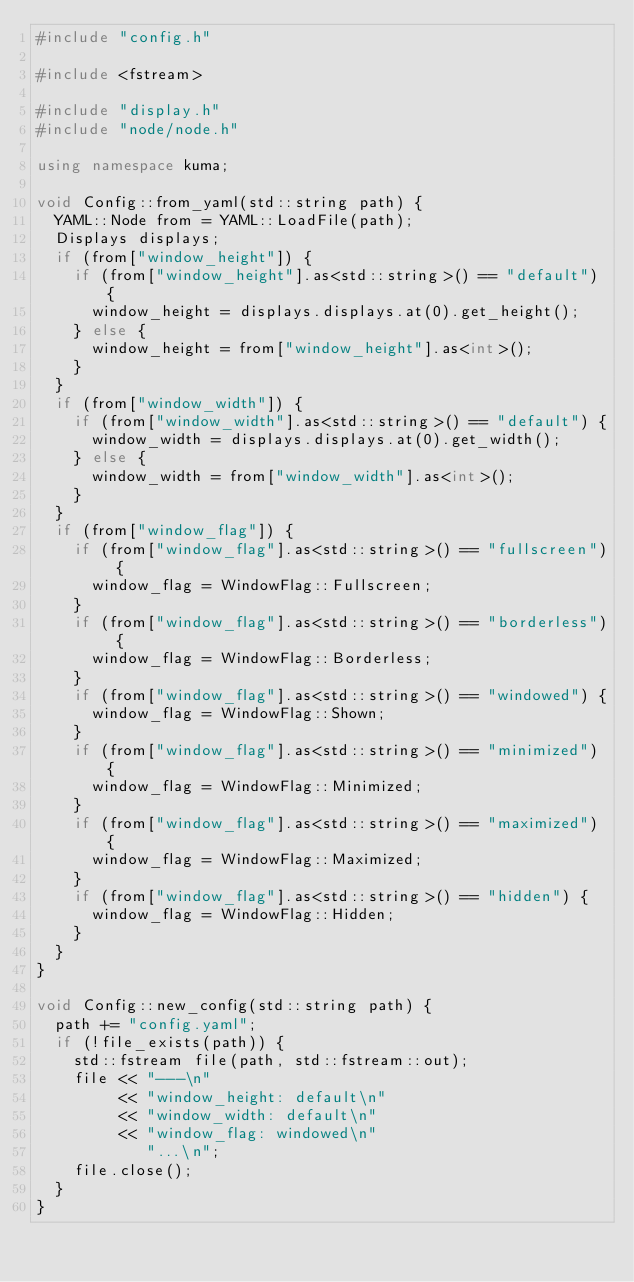<code> <loc_0><loc_0><loc_500><loc_500><_C++_>#include "config.h"

#include <fstream>

#include "display.h"
#include "node/node.h"

using namespace kuma;

void Config::from_yaml(std::string path) {
	YAML::Node from = YAML::LoadFile(path);
	Displays displays;
	if (from["window_height"]) {
		if (from["window_height"].as<std::string>() == "default") {
			window_height = displays.displays.at(0).get_height();
		} else {
			window_height = from["window_height"].as<int>();
		}
	}
	if (from["window_width"]) {
		if (from["window_width"].as<std::string>() == "default") {
			window_width = displays.displays.at(0).get_width();
		} else {
			window_width = from["window_width"].as<int>();
		}
	}
	if (from["window_flag"]) {
		if (from["window_flag"].as<std::string>() == "fullscreen") {
			window_flag = WindowFlag::Fullscreen;
		}
		if (from["window_flag"].as<std::string>() == "borderless") {
			window_flag = WindowFlag::Borderless;
		}
		if (from["window_flag"].as<std::string>() == "windowed") {
			window_flag = WindowFlag::Shown;
		}
		if (from["window_flag"].as<std::string>() == "minimized") {
			window_flag = WindowFlag::Minimized;
		}
		if (from["window_flag"].as<std::string>() == "maximized") {
			window_flag = WindowFlag::Maximized;
		}
		if (from["window_flag"].as<std::string>() == "hidden") {
			window_flag = WindowFlag::Hidden;
		}
	}
}

void Config::new_config(std::string path) {
	path += "config.yaml";
	if (!file_exists(path)) {
		std::fstream file(path, std::fstream::out);
		file << "---\n"
		     << "window_height: default\n"
		     << "window_width: default\n"
		     << "window_flag: windowed\n"
		        "...\n";
		file.close();
	}
}
</code> 